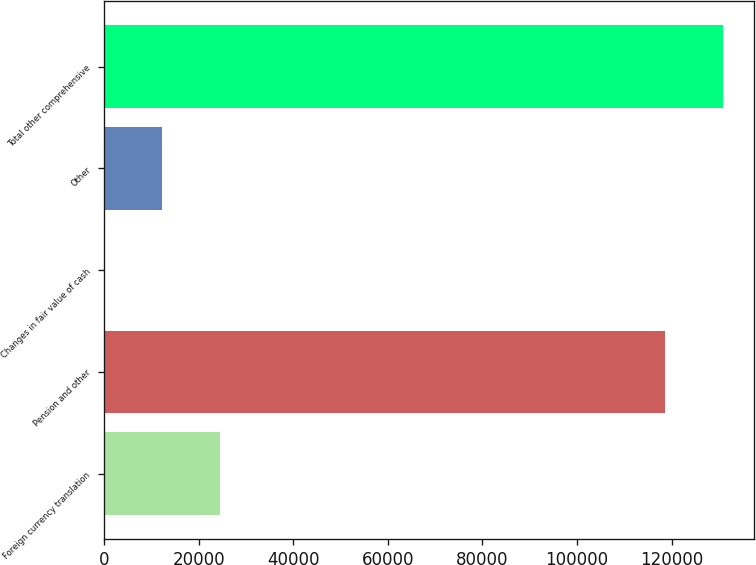Convert chart to OTSL. <chart><loc_0><loc_0><loc_500><loc_500><bar_chart><fcel>Foreign currency translation<fcel>Pension and other<fcel>Changes in fair value of cash<fcel>Other<fcel>Total other comprehensive<nl><fcel>24565<fcel>118507<fcel>49<fcel>12307<fcel>130765<nl></chart> 